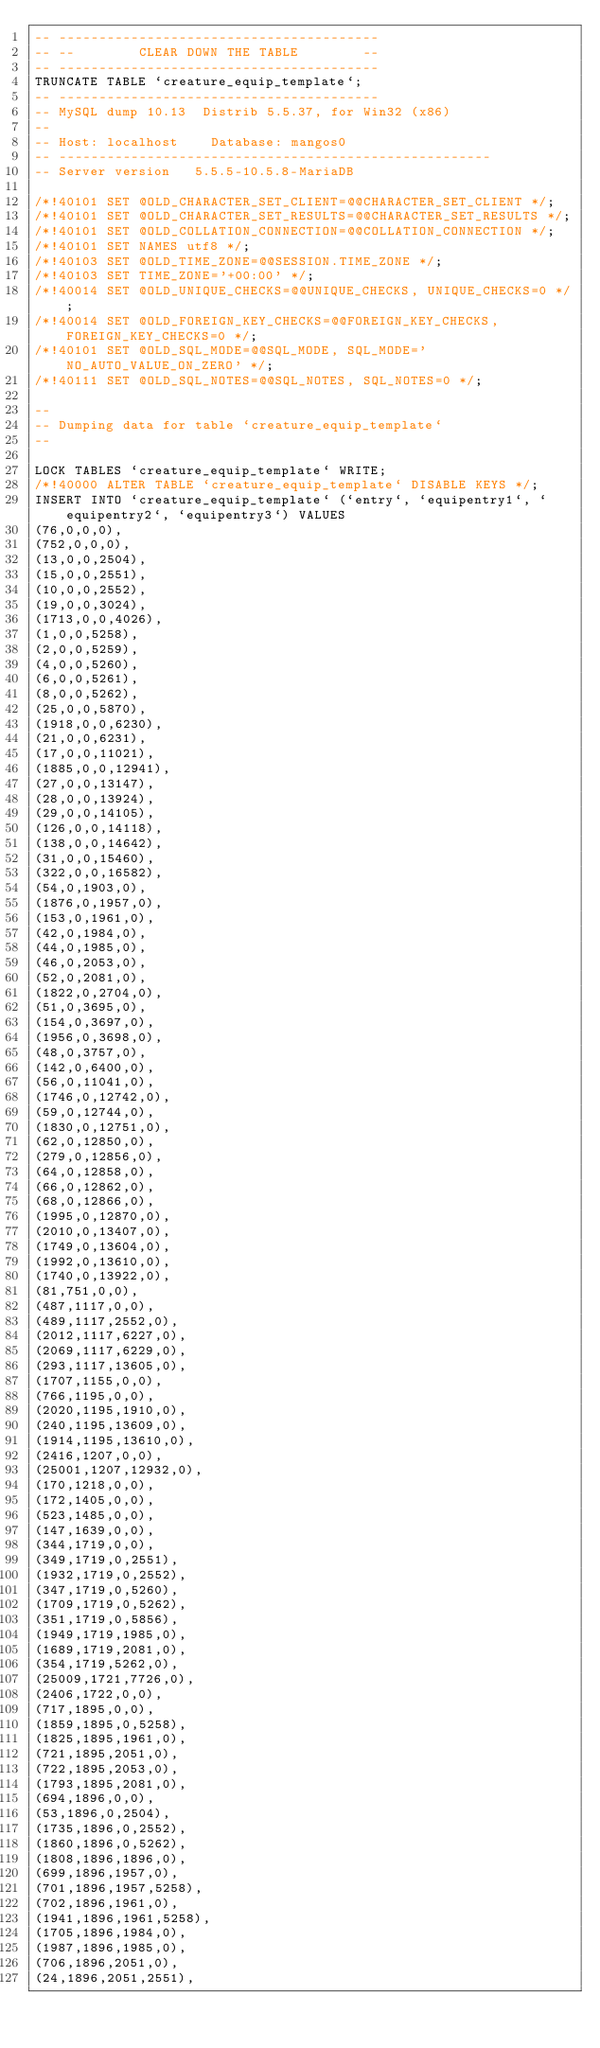Convert code to text. <code><loc_0><loc_0><loc_500><loc_500><_SQL_>-- ---------------------------------------- 
-- --        CLEAR DOWN THE TABLE        -- 
-- ---------------------------------------- 
TRUNCATE TABLE `creature_equip_template`; 
-- ---------------------------------------- 
-- MySQL dump 10.13  Distrib 5.5.37, for Win32 (x86)
--
-- Host: localhost    Database: mangos0
-- ------------------------------------------------------
-- Server version	5.5.5-10.5.8-MariaDB

/*!40101 SET @OLD_CHARACTER_SET_CLIENT=@@CHARACTER_SET_CLIENT */;
/*!40101 SET @OLD_CHARACTER_SET_RESULTS=@@CHARACTER_SET_RESULTS */;
/*!40101 SET @OLD_COLLATION_CONNECTION=@@COLLATION_CONNECTION */;
/*!40101 SET NAMES utf8 */;
/*!40103 SET @OLD_TIME_ZONE=@@SESSION.TIME_ZONE */;
/*!40103 SET TIME_ZONE='+00:00' */;
/*!40014 SET @OLD_UNIQUE_CHECKS=@@UNIQUE_CHECKS, UNIQUE_CHECKS=0 */;
/*!40014 SET @OLD_FOREIGN_KEY_CHECKS=@@FOREIGN_KEY_CHECKS, FOREIGN_KEY_CHECKS=0 */;
/*!40101 SET @OLD_SQL_MODE=@@SQL_MODE, SQL_MODE='NO_AUTO_VALUE_ON_ZERO' */;
/*!40111 SET @OLD_SQL_NOTES=@@SQL_NOTES, SQL_NOTES=0 */;

--
-- Dumping data for table `creature_equip_template`
--

LOCK TABLES `creature_equip_template` WRITE;
/*!40000 ALTER TABLE `creature_equip_template` DISABLE KEYS */;
INSERT INTO `creature_equip_template` (`entry`, `equipentry1`, `equipentry2`, `equipentry3`) VALUES 
(76,0,0,0),
(752,0,0,0),
(13,0,0,2504),
(15,0,0,2551),
(10,0,0,2552),
(19,0,0,3024),
(1713,0,0,4026),
(1,0,0,5258),
(2,0,0,5259),
(4,0,0,5260),
(6,0,0,5261),
(8,0,0,5262),
(25,0,0,5870),
(1918,0,0,6230),
(21,0,0,6231),
(17,0,0,11021),
(1885,0,0,12941),
(27,0,0,13147),
(28,0,0,13924),
(29,0,0,14105),
(126,0,0,14118),
(138,0,0,14642),
(31,0,0,15460),
(322,0,0,16582),
(54,0,1903,0),
(1876,0,1957,0),
(153,0,1961,0),
(42,0,1984,0),
(44,0,1985,0),
(46,0,2053,0),
(52,0,2081,0),
(1822,0,2704,0),
(51,0,3695,0),
(154,0,3697,0),
(1956,0,3698,0),
(48,0,3757,0),
(142,0,6400,0),
(56,0,11041,0),
(1746,0,12742,0),
(59,0,12744,0),
(1830,0,12751,0),
(62,0,12850,0),
(279,0,12856,0),
(64,0,12858,0),
(66,0,12862,0),
(68,0,12866,0),
(1995,0,12870,0),
(2010,0,13407,0),
(1749,0,13604,0),
(1992,0,13610,0),
(1740,0,13922,0),
(81,751,0,0),
(487,1117,0,0),
(489,1117,2552,0),
(2012,1117,6227,0),
(2069,1117,6229,0),
(293,1117,13605,0),
(1707,1155,0,0),
(766,1195,0,0),
(2020,1195,1910,0),
(240,1195,13609,0),
(1914,1195,13610,0),
(2416,1207,0,0),
(25001,1207,12932,0),
(170,1218,0,0),
(172,1405,0,0),
(523,1485,0,0),
(147,1639,0,0),
(344,1719,0,0),
(349,1719,0,2551),
(1932,1719,0,2552),
(347,1719,0,5260),
(1709,1719,0,5262),
(351,1719,0,5856),
(1949,1719,1985,0),
(1689,1719,2081,0),
(354,1719,5262,0),
(25009,1721,7726,0),
(2406,1722,0,0),
(717,1895,0,0),
(1859,1895,0,5258),
(1825,1895,1961,0),
(721,1895,2051,0),
(722,1895,2053,0),
(1793,1895,2081,0),
(694,1896,0,0),
(53,1896,0,2504),
(1735,1896,0,2552),
(1860,1896,0,5262),
(1808,1896,1896,0),
(699,1896,1957,0),
(701,1896,1957,5258),
(702,1896,1961,0),
(1941,1896,1961,5258),
(1705,1896,1984,0),
(1987,1896,1985,0),
(706,1896,2051,0),
(24,1896,2051,2551),</code> 